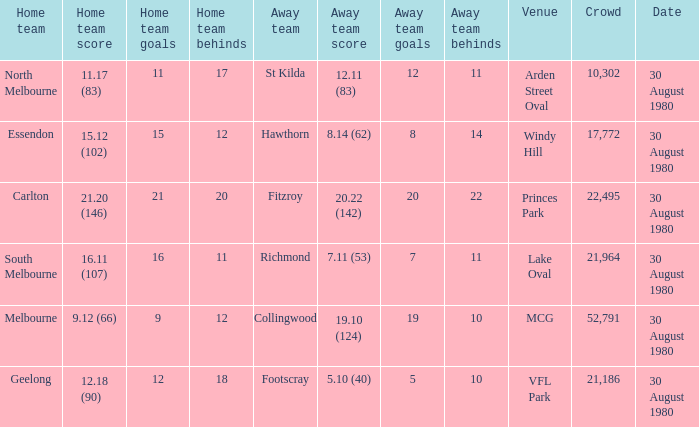What is the home team score at lake oval? 16.11 (107). 